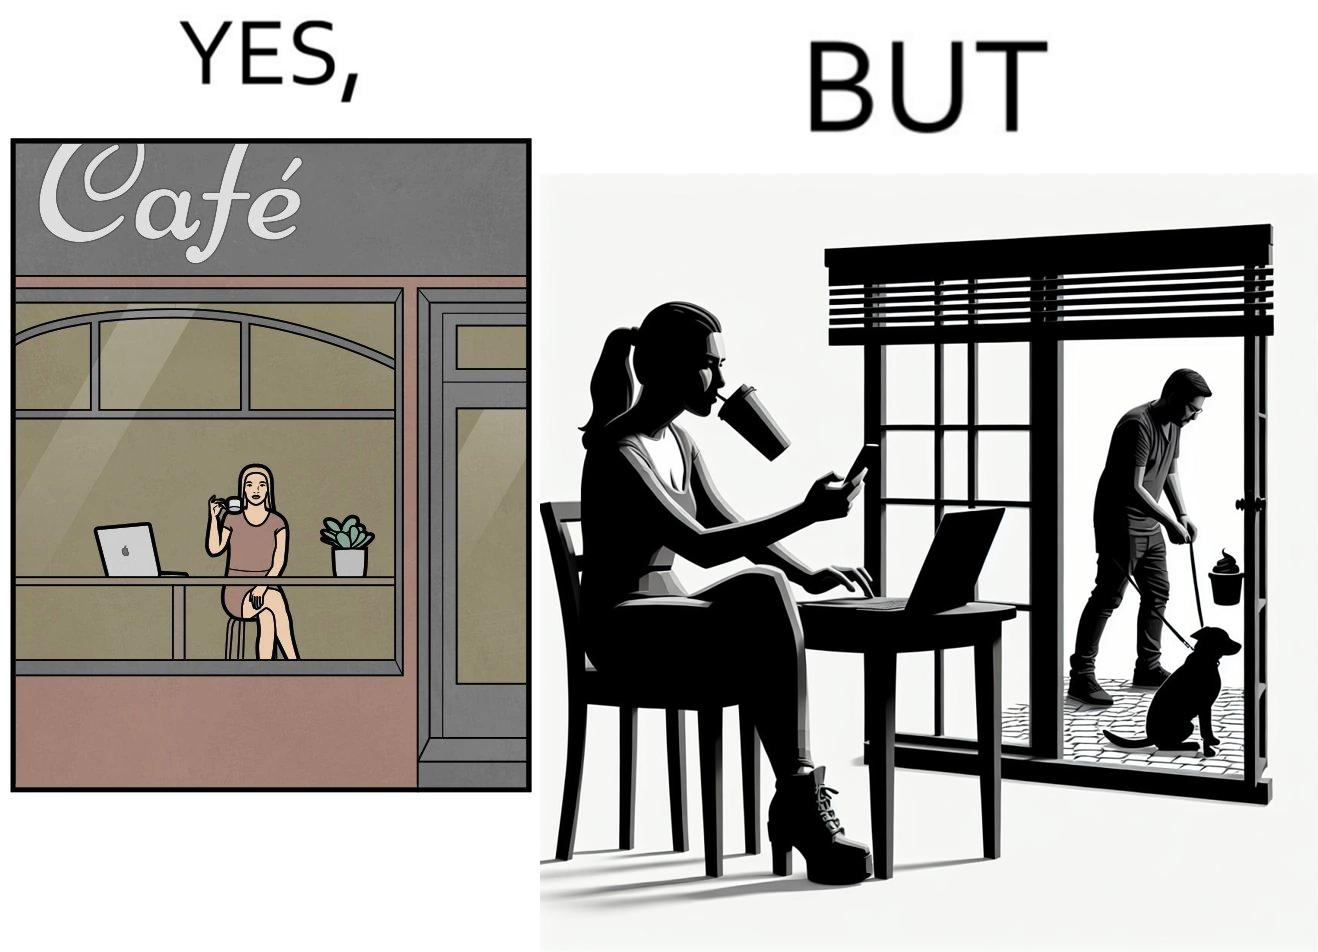Describe what you see in the left and right parts of this image. In the left part of the image: a woman looking through the window from a cafe while enjoying her drink with working on her laptop In the right part of the image: a woman enjoying her drink and working at laptop while looking outside through the window at a person who is out for getting his dog pooped outside 